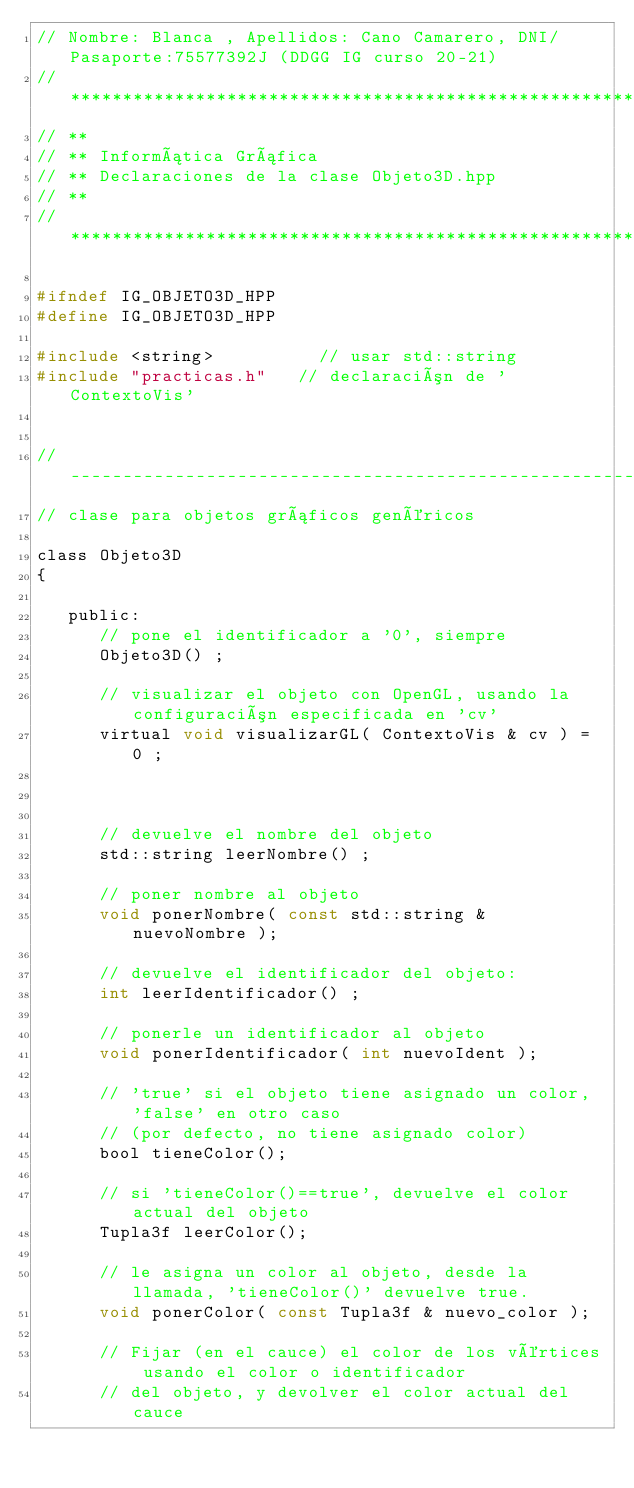<code> <loc_0><loc_0><loc_500><loc_500><_C_>// Nombre: Blanca , Apellidos: Cano Camarero, DNI/Pasaporte:75577392J (DDGG IG curso 20-21)
// *********************************************************************
// **
// ** Informática Gráfica
// ** Declaraciones de la clase Objeto3D.hpp
// **
// *********************************************************************

#ifndef IG_OBJETO3D_HPP
#define IG_OBJETO3D_HPP

#include <string>          // usar std::string
#include "practicas.h"   // declaración de 'ContextoVis'


// ---------------------------------------------------------------------
// clase para objetos gráficos genéricos

class Objeto3D
{

   public:
      // pone el identificador a '0', siempre
      Objeto3D() ;

      // visualizar el objeto con OpenGL, usando la configuración especificada en 'cv'
      virtual void visualizarGL( ContextoVis & cv ) = 0 ;



      // devuelve el nombre del objeto
      std::string leerNombre() ;

      // poner nombre al objeto
      void ponerNombre( const std::string & nuevoNombre );

      // devuelve el identificador del objeto:
      int leerIdentificador() ;

      // ponerle un identificador al objeto
      void ponerIdentificador( int nuevoIdent );

      // 'true' si el objeto tiene asignado un color, 'false' en otro caso
      // (por defecto, no tiene asignado color)
      bool tieneColor();

      // si 'tieneColor()==true', devuelve el color actual del objeto
      Tupla3f leerColor();

      // le asigna un color al objeto, desde la llamada, 'tieneColor()' devuelve true.
      void ponerColor( const Tupla3f & nuevo_color );

      // Fijar (en el cauce) el color de los vértices usando el color o identificador
      // del objeto, y devolver el color actual del cauce</code> 